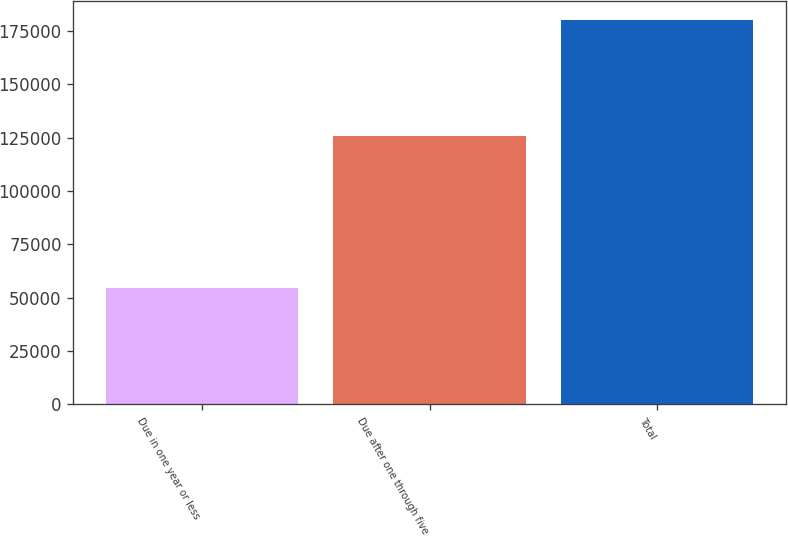Convert chart to OTSL. <chart><loc_0><loc_0><loc_500><loc_500><bar_chart><fcel>Due in one year or less<fcel>Due after one through five<fcel>Total<nl><fcel>54543<fcel>125775<fcel>180318<nl></chart> 